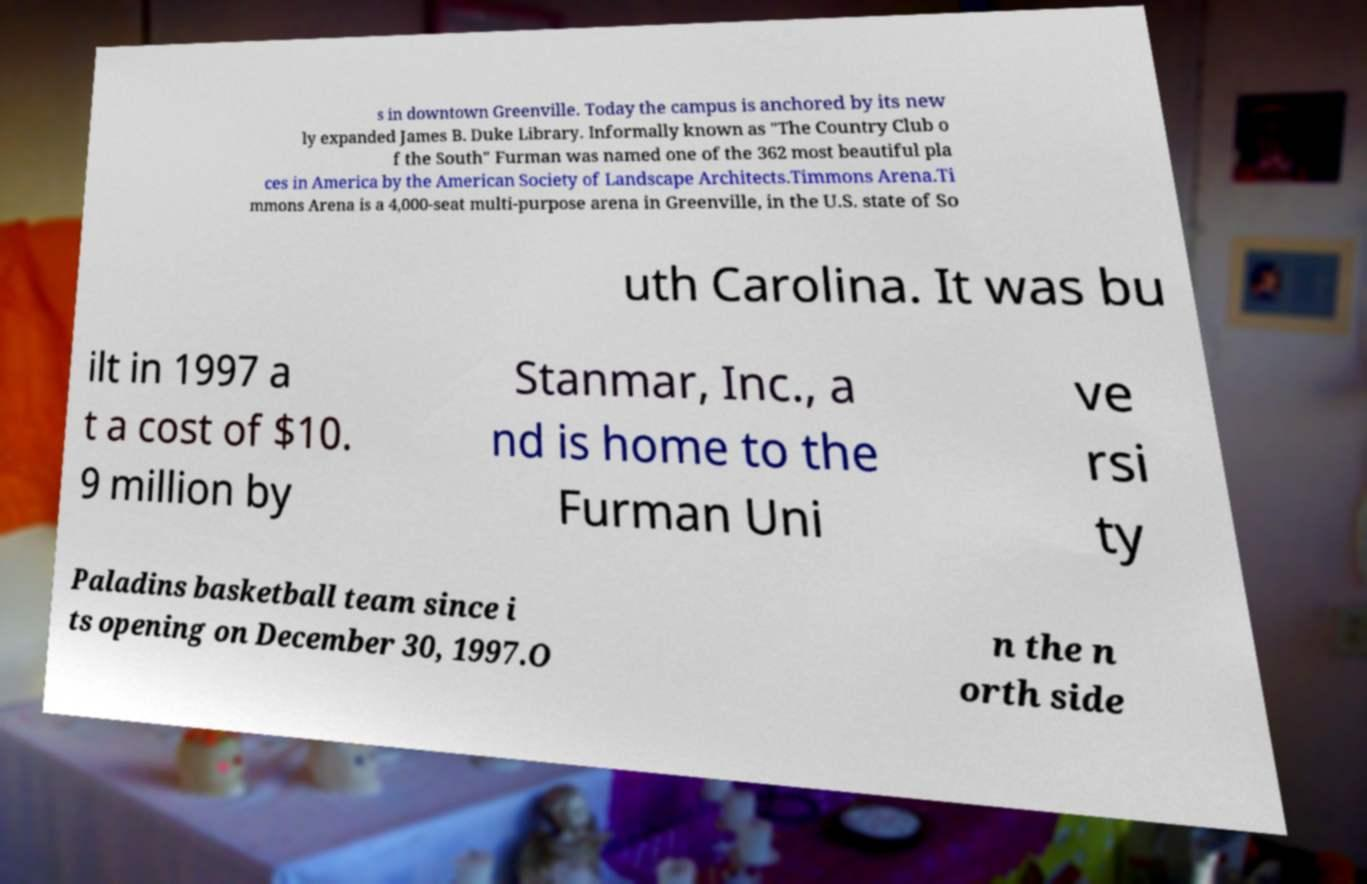Could you assist in decoding the text presented in this image and type it out clearly? s in downtown Greenville. Today the campus is anchored by its new ly expanded James B. Duke Library. Informally known as "The Country Club o f the South" Furman was named one of the 362 most beautiful pla ces in America by the American Society of Landscape Architects.Timmons Arena.Ti mmons Arena is a 4,000-seat multi-purpose arena in Greenville, in the U.S. state of So uth Carolina. It was bu ilt in 1997 a t a cost of $10. 9 million by Stanmar, Inc., a nd is home to the Furman Uni ve rsi ty Paladins basketball team since i ts opening on December 30, 1997.O n the n orth side 